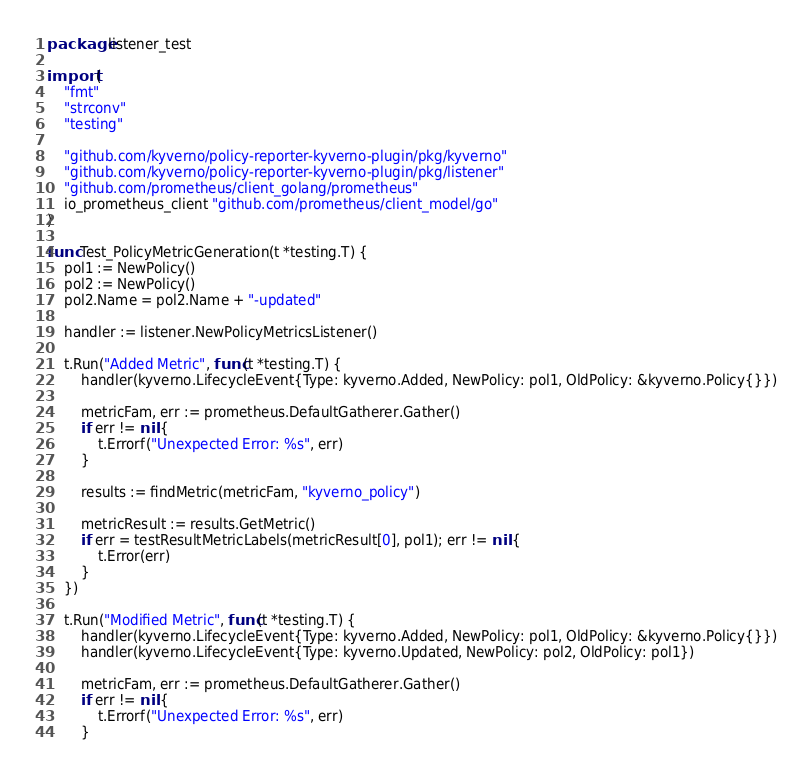<code> <loc_0><loc_0><loc_500><loc_500><_Go_>package listener_test

import (
	"fmt"
	"strconv"
	"testing"

	"github.com/kyverno/policy-reporter-kyverno-plugin/pkg/kyverno"
	"github.com/kyverno/policy-reporter-kyverno-plugin/pkg/listener"
	"github.com/prometheus/client_golang/prometheus"
	io_prometheus_client "github.com/prometheus/client_model/go"
)

func Test_PolicyMetricGeneration(t *testing.T) {
	pol1 := NewPolicy()
	pol2 := NewPolicy()
	pol2.Name = pol2.Name + "-updated"

	handler := listener.NewPolicyMetricsListener()

	t.Run("Added Metric", func(t *testing.T) {
		handler(kyverno.LifecycleEvent{Type: kyverno.Added, NewPolicy: pol1, OldPolicy: &kyverno.Policy{}})

		metricFam, err := prometheus.DefaultGatherer.Gather()
		if err != nil {
			t.Errorf("Unexpected Error: %s", err)
		}

		results := findMetric(metricFam, "kyverno_policy")

		metricResult := results.GetMetric()
		if err = testResultMetricLabels(metricResult[0], pol1); err != nil {
			t.Error(err)
		}
	})

	t.Run("Modified Metric", func(t *testing.T) {
		handler(kyverno.LifecycleEvent{Type: kyverno.Added, NewPolicy: pol1, OldPolicy: &kyverno.Policy{}})
		handler(kyverno.LifecycleEvent{Type: kyverno.Updated, NewPolicy: pol2, OldPolicy: pol1})

		metricFam, err := prometheus.DefaultGatherer.Gather()
		if err != nil {
			t.Errorf("Unexpected Error: %s", err)
		}
</code> 